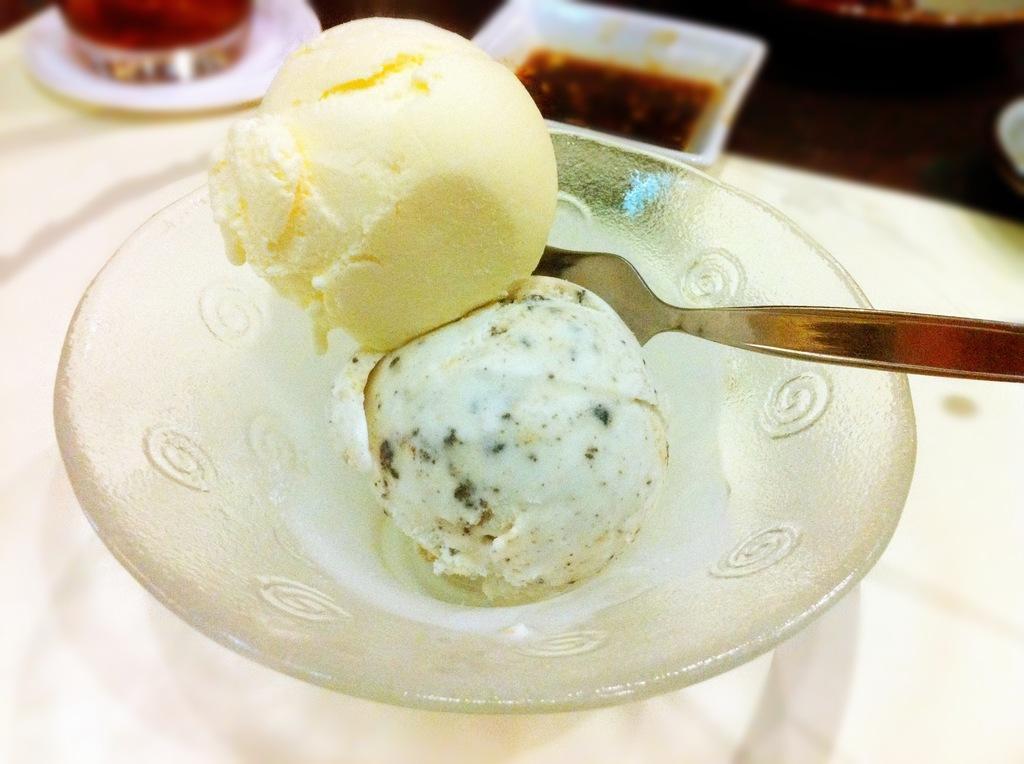How would you summarize this image in a sentence or two? In the foreground of this image, there are ice creams in a bowl along with a spoon on a table. At the top, there is a white bowl, saucer and a glass on the table. 